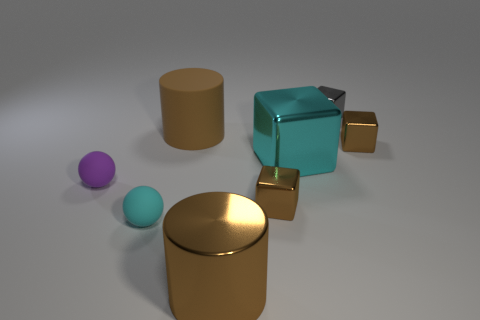Add 1 cyan rubber objects. How many objects exist? 9 Subtract all large cyan metallic cubes. How many cubes are left? 3 Subtract all cylinders. How many objects are left? 6 Subtract all cyan balls. How many balls are left? 1 Subtract 2 blocks. How many blocks are left? 2 Subtract all red cylinders. Subtract all yellow balls. How many cylinders are left? 2 Subtract all blue cylinders. How many blue balls are left? 0 Subtract all small purple shiny cylinders. Subtract all tiny spheres. How many objects are left? 6 Add 2 tiny brown cubes. How many tiny brown cubes are left? 4 Add 6 small shiny cubes. How many small shiny cubes exist? 9 